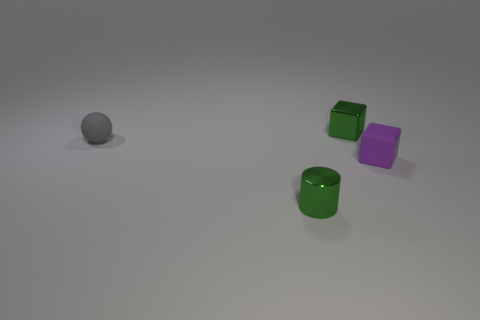Add 2 purple things. How many objects exist? 6 Subtract all cylinders. How many objects are left? 3 Subtract all small gray rubber things. Subtract all tiny rubber spheres. How many objects are left? 2 Add 2 gray spheres. How many gray spheres are left? 3 Add 2 small matte spheres. How many small matte spheres exist? 3 Subtract 1 purple cubes. How many objects are left? 3 